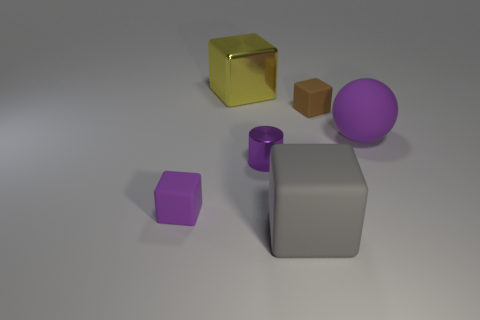How many other objects are there of the same material as the tiny cylinder?
Your answer should be very brief. 1. Are there more purple rubber objects than big purple balls?
Provide a succinct answer. Yes. Is the color of the small matte cube that is in front of the small purple shiny cylinder the same as the ball?
Ensure brevity in your answer.  Yes. What is the color of the metal cylinder?
Provide a succinct answer. Purple. Is there a brown matte object behind the small matte cube that is on the left side of the brown rubber block?
Offer a very short reply. Yes. What shape is the purple rubber object right of the tiny purple thing that is right of the big yellow thing?
Your answer should be very brief. Sphere. Are there fewer yellow things than big blue cylinders?
Your answer should be very brief. No. Does the big yellow object have the same material as the purple sphere?
Make the answer very short. No. What is the color of the thing that is both on the left side of the large purple sphere and on the right side of the gray matte block?
Ensure brevity in your answer.  Brown. Are there any red matte blocks that have the same size as the purple matte sphere?
Offer a terse response. No. 